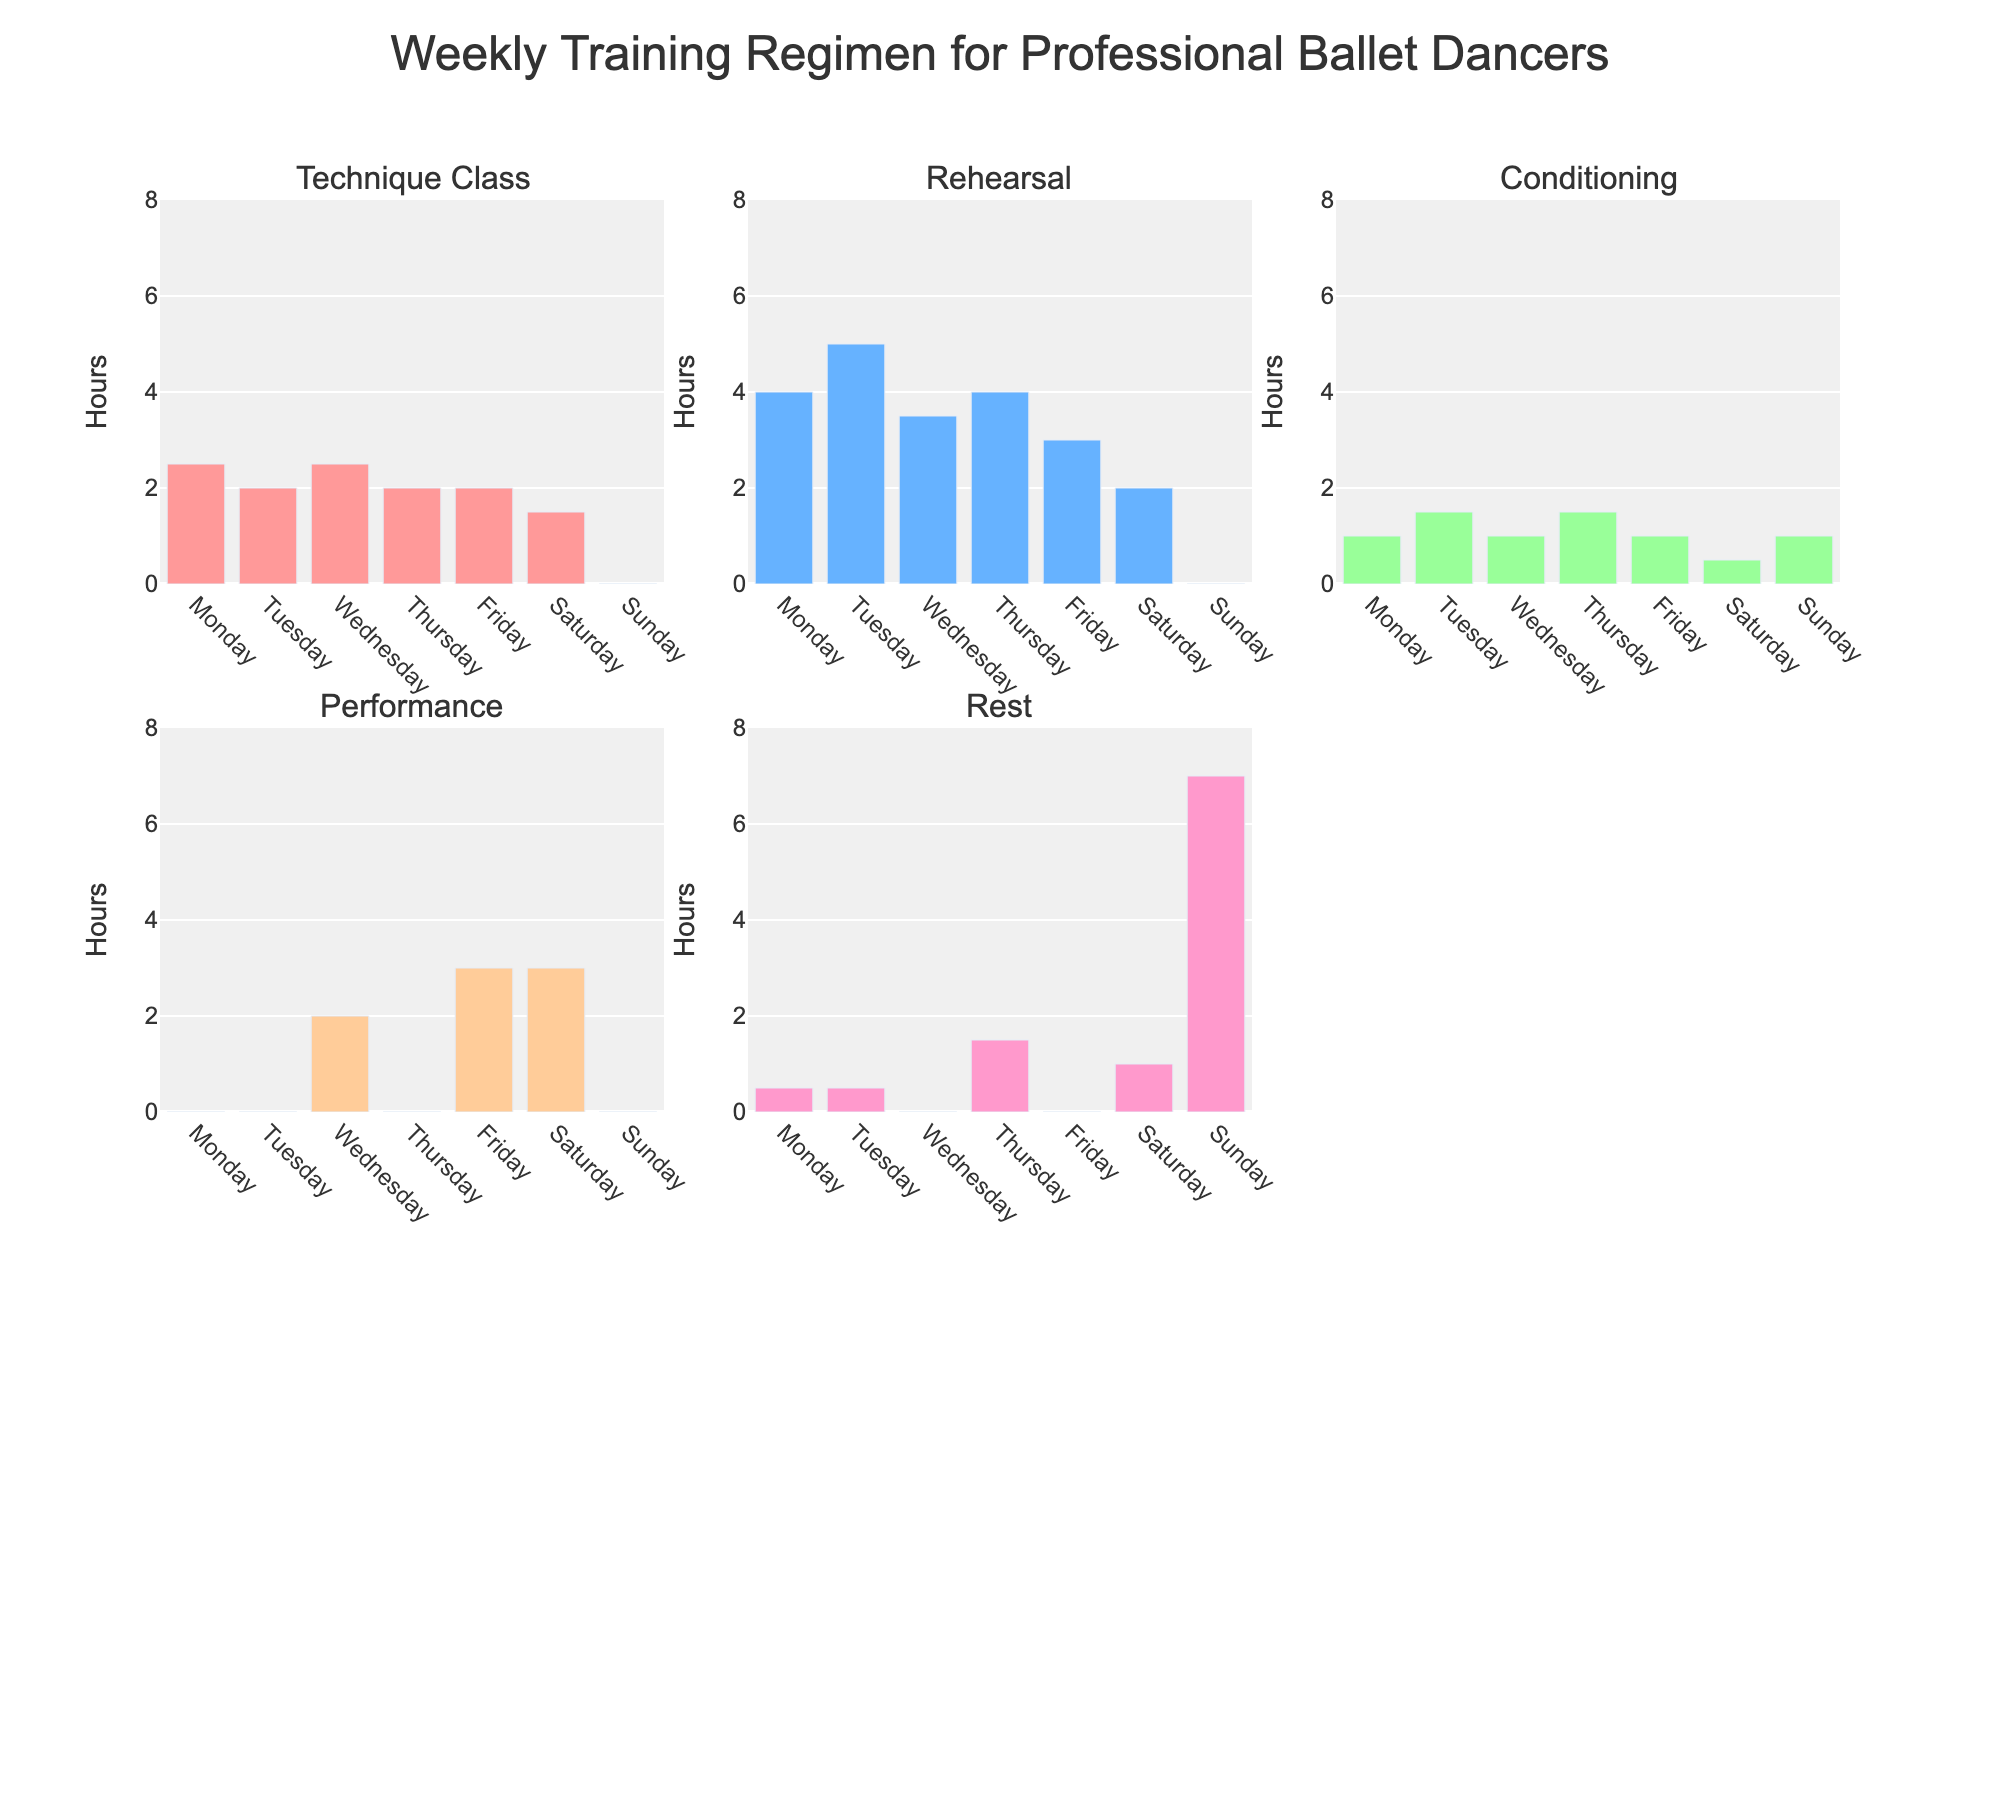Which job role had the highest turnover rate in Q1? From the charts, observe the bar height for each job role in the Q1 subplot. The highest bar represents the Cashier role.
Answer: Cashier What is the average turnover rate of the Store Manager across all quarters? Add the Store Manager's turnover rates for all quarters (2.1 + 2.3 + 2.5 + 2.7), and divide by the number of quarters (4). This results in (2.1 + 2.3 + 2.5 + 2.7)/4 = 2.4.
Answer: 2.4 Which quarter shows the lowest turnover rate for the Shift Supervisor? Look at the bar heights for the Shift Supervisor in each subplot (Q1, Q2, Q3, Q4). The shortest bar is in Q1.
Answer: Q1 How does the turnover rate for Sales Associates in Q3 compare to Q4? Compare the heights of the bars for Sales Associates in Q3 and Q4 subplots. The turnover rate increased from 12.4% in Q3 to 13.6% in Q4.
Answer: Increased Which job role had the most consistent turnover rate across the quarters? Evaluate the fluctuation of bars for each job role across all subplots. The Store Manager's bars show the least variation.
Answer: Store Manager If the overall turnover rate needs to be reduced to below 10%, which job roles require the most attention? Identify bars that exceed a 10% turnover rate in any quarter. Cashier, Stock Associate, and Sales Associate exceed this threshold consistently.
Answer: Cashier, Stock Associate, Sales Associate What is the difference between the highest and lowest turnover rates for the Assistant Manager in Q4? Find the highest and lowest turnover rates for the Assistant Manager in Q4 from the chart. The highest is 5.5% and the lowest is in Q1 at 4.3%. The difference is 5.5% - 4.3% = 1.2%.
Answer: 1.2% What is the turnover trend for the Department Manager from Q1 to Q4? Observe the bar heights for the Department Manager in each subplot sequentially. The trend shows an increase from 5.6% in Q1 to 6.8% in Q4, indicating a rising trend.
Answer: Rising Is there any job role with a turnover rate below 5% in Q3? Check each bar in the Q3 subplot for any height below 5%. The Store Manager and Assistant Manager both have rates below 5% (2.5% and 4.5% respectively).
Answer: Yes What is the total turnover rate for Shift Supervisors combining all quarters? Add the turnover rates for Shift Supervisors across all quarters (3.9 + 4.1 + 4.5 + 4.8). This results in a sum of 17.3%.
Answer: 17.3% 